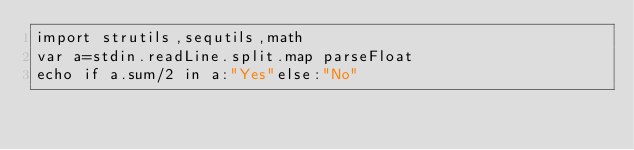Convert code to text. <code><loc_0><loc_0><loc_500><loc_500><_Nim_>import strutils,sequtils,math
var a=stdin.readLine.split.map parseFloat
echo if a.sum/2 in a:"Yes"else:"No"</code> 